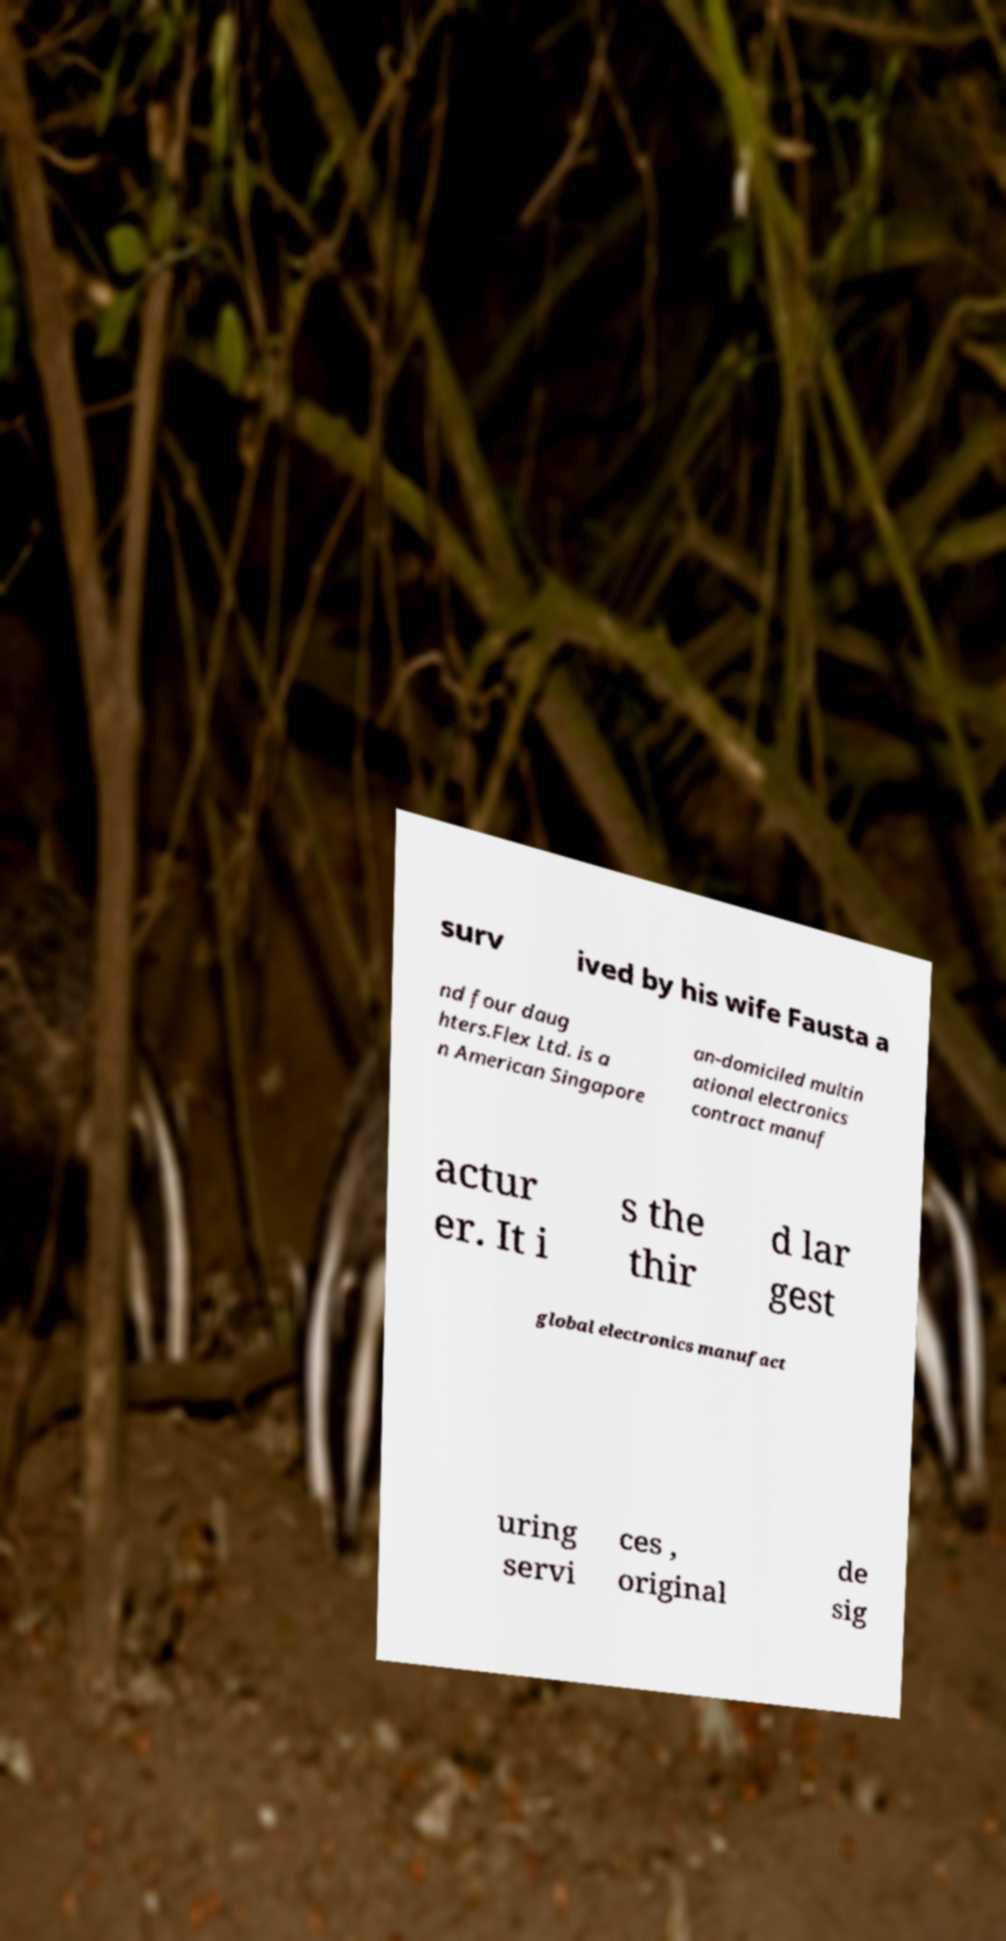Please identify and transcribe the text found in this image. surv ived by his wife Fausta a nd four daug hters.Flex Ltd. is a n American Singapore an-domiciled multin ational electronics contract manuf actur er. It i s the thir d lar gest global electronics manufact uring servi ces , original de sig 